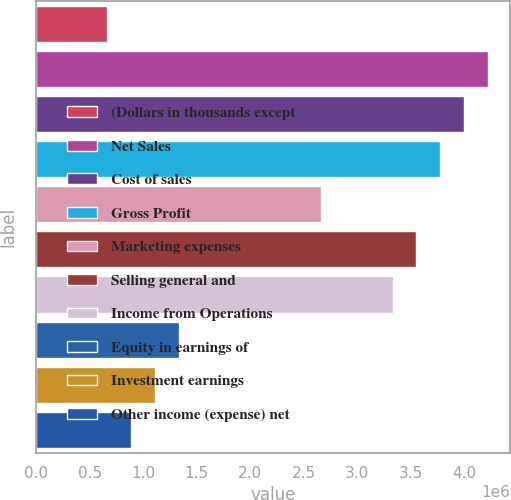<chart> <loc_0><loc_0><loc_500><loc_500><bar_chart><fcel>(Dollars in thousands except<fcel>Net Sales<fcel>Cost of sales<fcel>Gross Profit<fcel>Marketing expenses<fcel>Selling general and<fcel>Income from Operations<fcel>Equity in earnings of<fcel>Investment earnings<fcel>Other income (expense) net<nl><fcel>666284<fcel>4.21978e+06<fcel>3.99769e+06<fcel>3.7756e+06<fcel>2.66513e+06<fcel>3.5535e+06<fcel>3.33141e+06<fcel>1.33256e+06<fcel>1.11047e+06<fcel>888377<nl></chart> 